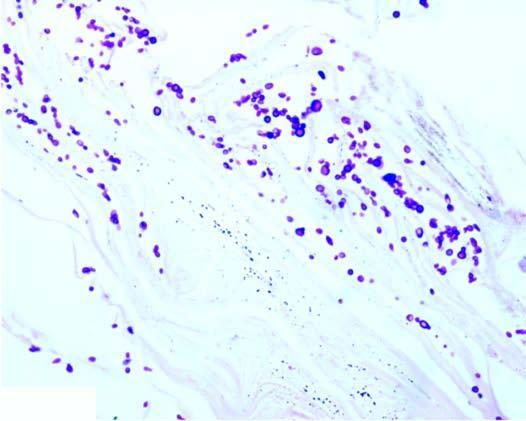does the smear show presence of numerous arthrospores and hyphae?
Answer the question using a single word or phrase. No 